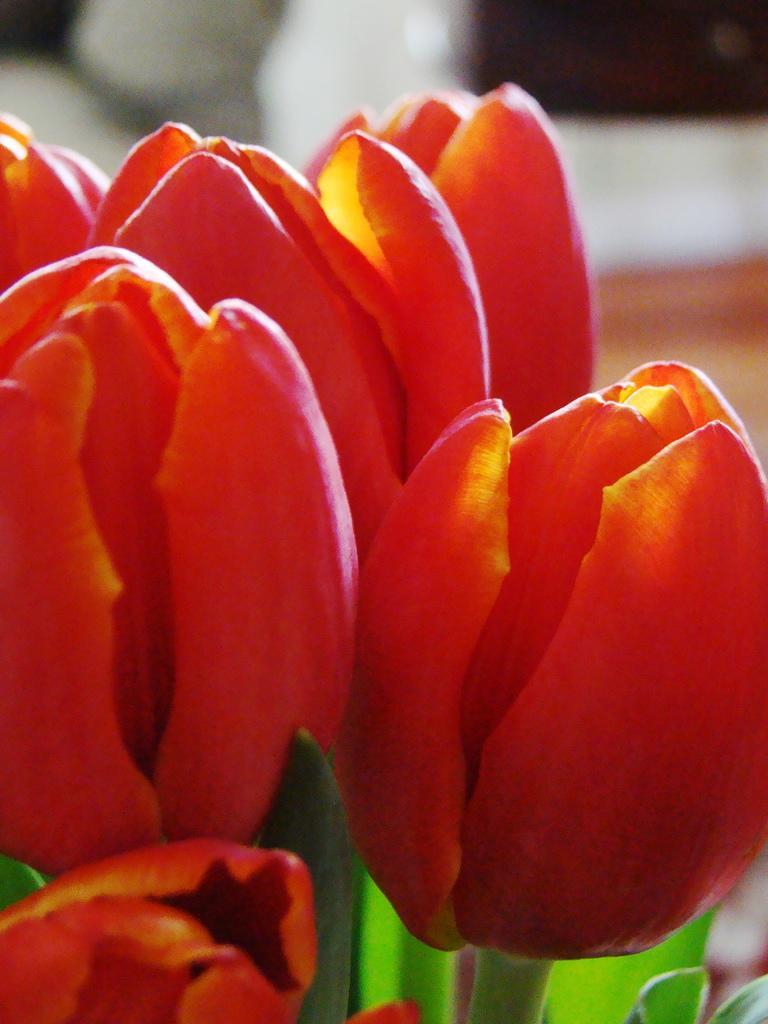Could you give a brief overview of what you see in this image? In the image there are beautiful flowers and the background of the flowers is blur. 